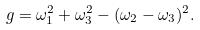<formula> <loc_0><loc_0><loc_500><loc_500>g = \omega ^ { 2 } _ { 1 } + \omega ^ { 2 } _ { 3 } - ( \omega _ { 2 } - \omega _ { 3 } ) ^ { 2 } .</formula> 